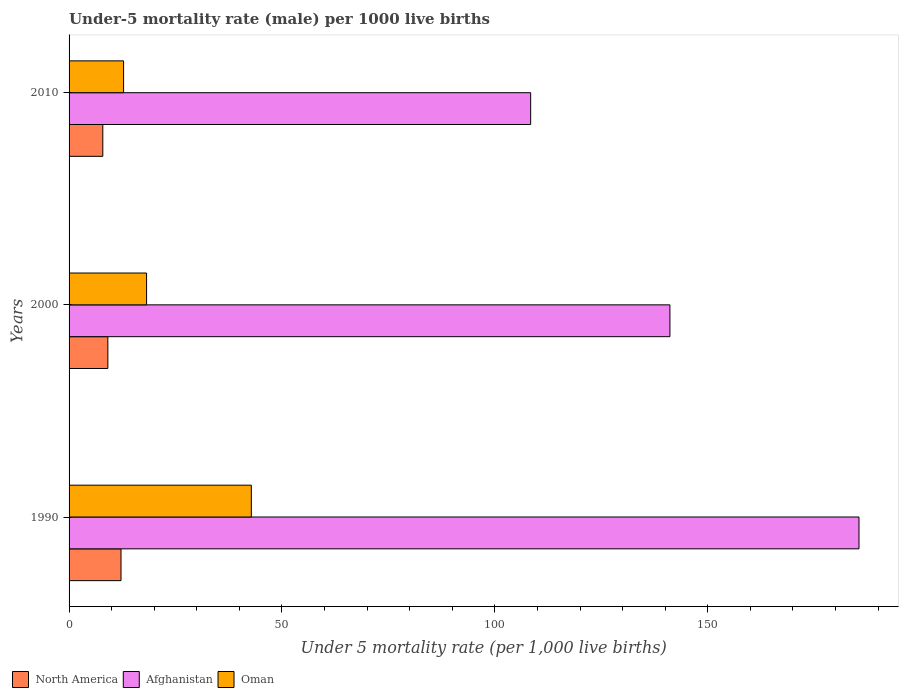Are the number of bars per tick equal to the number of legend labels?
Your answer should be compact. Yes. What is the label of the 3rd group of bars from the top?
Offer a very short reply. 1990. What is the under-five mortality rate in North America in 1990?
Provide a succinct answer. 12.2. Across all years, what is the maximum under-five mortality rate in North America?
Keep it short and to the point. 12.2. What is the total under-five mortality rate in Oman in the graph?
Provide a short and direct response. 73.8. What is the difference between the under-five mortality rate in Oman in 1990 and that in 2010?
Give a very brief answer. 30. What is the difference between the under-five mortality rate in Oman in 2010 and the under-five mortality rate in North America in 2000?
Offer a very short reply. 3.69. What is the average under-five mortality rate in Oman per year?
Make the answer very short. 24.6. In the year 2010, what is the difference between the under-five mortality rate in Oman and under-five mortality rate in Afghanistan?
Provide a succinct answer. -95.6. What is the ratio of the under-five mortality rate in Oman in 1990 to that in 2010?
Provide a short and direct response. 3.34. Is the under-five mortality rate in Afghanistan in 1990 less than that in 2010?
Your response must be concise. No. Is the difference between the under-five mortality rate in Oman in 2000 and 2010 greater than the difference between the under-five mortality rate in Afghanistan in 2000 and 2010?
Your answer should be compact. No. What is the difference between the highest and the second highest under-five mortality rate in Afghanistan?
Offer a terse response. 44.4. What is the difference between the highest and the lowest under-five mortality rate in North America?
Keep it short and to the point. 4.28. Is the sum of the under-five mortality rate in Oman in 2000 and 2010 greater than the maximum under-five mortality rate in Afghanistan across all years?
Make the answer very short. No. What does the 1st bar from the top in 2000 represents?
Offer a terse response. Oman. What does the 3rd bar from the bottom in 1990 represents?
Offer a very short reply. Oman. Is it the case that in every year, the sum of the under-five mortality rate in North America and under-five mortality rate in Afghanistan is greater than the under-five mortality rate in Oman?
Keep it short and to the point. Yes. Are all the bars in the graph horizontal?
Your answer should be very brief. Yes. Does the graph contain grids?
Offer a very short reply. No. Where does the legend appear in the graph?
Give a very brief answer. Bottom left. How are the legend labels stacked?
Keep it short and to the point. Horizontal. What is the title of the graph?
Make the answer very short. Under-5 mortality rate (male) per 1000 live births. What is the label or title of the X-axis?
Give a very brief answer. Under 5 mortality rate (per 1,0 live births). What is the label or title of the Y-axis?
Give a very brief answer. Years. What is the Under 5 mortality rate (per 1,000 live births) in North America in 1990?
Offer a very short reply. 12.2. What is the Under 5 mortality rate (per 1,000 live births) in Afghanistan in 1990?
Offer a very short reply. 185.5. What is the Under 5 mortality rate (per 1,000 live births) of Oman in 1990?
Your answer should be compact. 42.8. What is the Under 5 mortality rate (per 1,000 live births) of North America in 2000?
Keep it short and to the point. 9.11. What is the Under 5 mortality rate (per 1,000 live births) in Afghanistan in 2000?
Your response must be concise. 141.1. What is the Under 5 mortality rate (per 1,000 live births) of North America in 2010?
Your answer should be compact. 7.92. What is the Under 5 mortality rate (per 1,000 live births) of Afghanistan in 2010?
Your answer should be very brief. 108.4. Across all years, what is the maximum Under 5 mortality rate (per 1,000 live births) in North America?
Your answer should be compact. 12.2. Across all years, what is the maximum Under 5 mortality rate (per 1,000 live births) in Afghanistan?
Offer a terse response. 185.5. Across all years, what is the maximum Under 5 mortality rate (per 1,000 live births) in Oman?
Give a very brief answer. 42.8. Across all years, what is the minimum Under 5 mortality rate (per 1,000 live births) in North America?
Your answer should be very brief. 7.92. Across all years, what is the minimum Under 5 mortality rate (per 1,000 live births) in Afghanistan?
Give a very brief answer. 108.4. What is the total Under 5 mortality rate (per 1,000 live births) of North America in the graph?
Give a very brief answer. 29.23. What is the total Under 5 mortality rate (per 1,000 live births) of Afghanistan in the graph?
Offer a very short reply. 435. What is the total Under 5 mortality rate (per 1,000 live births) of Oman in the graph?
Your answer should be compact. 73.8. What is the difference between the Under 5 mortality rate (per 1,000 live births) of North America in 1990 and that in 2000?
Give a very brief answer. 3.09. What is the difference between the Under 5 mortality rate (per 1,000 live births) in Afghanistan in 1990 and that in 2000?
Your answer should be compact. 44.4. What is the difference between the Under 5 mortality rate (per 1,000 live births) of Oman in 1990 and that in 2000?
Offer a very short reply. 24.6. What is the difference between the Under 5 mortality rate (per 1,000 live births) of North America in 1990 and that in 2010?
Make the answer very short. 4.28. What is the difference between the Under 5 mortality rate (per 1,000 live births) of Afghanistan in 1990 and that in 2010?
Ensure brevity in your answer.  77.1. What is the difference between the Under 5 mortality rate (per 1,000 live births) in Oman in 1990 and that in 2010?
Keep it short and to the point. 30. What is the difference between the Under 5 mortality rate (per 1,000 live births) in North America in 2000 and that in 2010?
Your response must be concise. 1.19. What is the difference between the Under 5 mortality rate (per 1,000 live births) in Afghanistan in 2000 and that in 2010?
Give a very brief answer. 32.7. What is the difference between the Under 5 mortality rate (per 1,000 live births) in Oman in 2000 and that in 2010?
Keep it short and to the point. 5.4. What is the difference between the Under 5 mortality rate (per 1,000 live births) of North America in 1990 and the Under 5 mortality rate (per 1,000 live births) of Afghanistan in 2000?
Your response must be concise. -128.9. What is the difference between the Under 5 mortality rate (per 1,000 live births) in North America in 1990 and the Under 5 mortality rate (per 1,000 live births) in Oman in 2000?
Make the answer very short. -6. What is the difference between the Under 5 mortality rate (per 1,000 live births) in Afghanistan in 1990 and the Under 5 mortality rate (per 1,000 live births) in Oman in 2000?
Offer a very short reply. 167.3. What is the difference between the Under 5 mortality rate (per 1,000 live births) in North America in 1990 and the Under 5 mortality rate (per 1,000 live births) in Afghanistan in 2010?
Make the answer very short. -96.2. What is the difference between the Under 5 mortality rate (per 1,000 live births) of North America in 1990 and the Under 5 mortality rate (per 1,000 live births) of Oman in 2010?
Make the answer very short. -0.6. What is the difference between the Under 5 mortality rate (per 1,000 live births) in Afghanistan in 1990 and the Under 5 mortality rate (per 1,000 live births) in Oman in 2010?
Your answer should be compact. 172.7. What is the difference between the Under 5 mortality rate (per 1,000 live births) of North America in 2000 and the Under 5 mortality rate (per 1,000 live births) of Afghanistan in 2010?
Ensure brevity in your answer.  -99.29. What is the difference between the Under 5 mortality rate (per 1,000 live births) in North America in 2000 and the Under 5 mortality rate (per 1,000 live births) in Oman in 2010?
Your response must be concise. -3.69. What is the difference between the Under 5 mortality rate (per 1,000 live births) of Afghanistan in 2000 and the Under 5 mortality rate (per 1,000 live births) of Oman in 2010?
Provide a short and direct response. 128.3. What is the average Under 5 mortality rate (per 1,000 live births) of North America per year?
Make the answer very short. 9.74. What is the average Under 5 mortality rate (per 1,000 live births) in Afghanistan per year?
Your answer should be compact. 145. What is the average Under 5 mortality rate (per 1,000 live births) in Oman per year?
Offer a very short reply. 24.6. In the year 1990, what is the difference between the Under 5 mortality rate (per 1,000 live births) in North America and Under 5 mortality rate (per 1,000 live births) in Afghanistan?
Your answer should be very brief. -173.3. In the year 1990, what is the difference between the Under 5 mortality rate (per 1,000 live births) in North America and Under 5 mortality rate (per 1,000 live births) in Oman?
Make the answer very short. -30.6. In the year 1990, what is the difference between the Under 5 mortality rate (per 1,000 live births) of Afghanistan and Under 5 mortality rate (per 1,000 live births) of Oman?
Offer a very short reply. 142.7. In the year 2000, what is the difference between the Under 5 mortality rate (per 1,000 live births) of North America and Under 5 mortality rate (per 1,000 live births) of Afghanistan?
Make the answer very short. -131.99. In the year 2000, what is the difference between the Under 5 mortality rate (per 1,000 live births) in North America and Under 5 mortality rate (per 1,000 live births) in Oman?
Offer a terse response. -9.09. In the year 2000, what is the difference between the Under 5 mortality rate (per 1,000 live births) in Afghanistan and Under 5 mortality rate (per 1,000 live births) in Oman?
Provide a succinct answer. 122.9. In the year 2010, what is the difference between the Under 5 mortality rate (per 1,000 live births) in North America and Under 5 mortality rate (per 1,000 live births) in Afghanistan?
Provide a succinct answer. -100.48. In the year 2010, what is the difference between the Under 5 mortality rate (per 1,000 live births) in North America and Under 5 mortality rate (per 1,000 live births) in Oman?
Provide a succinct answer. -4.88. In the year 2010, what is the difference between the Under 5 mortality rate (per 1,000 live births) in Afghanistan and Under 5 mortality rate (per 1,000 live births) in Oman?
Ensure brevity in your answer.  95.6. What is the ratio of the Under 5 mortality rate (per 1,000 live births) in North America in 1990 to that in 2000?
Make the answer very short. 1.34. What is the ratio of the Under 5 mortality rate (per 1,000 live births) of Afghanistan in 1990 to that in 2000?
Your answer should be very brief. 1.31. What is the ratio of the Under 5 mortality rate (per 1,000 live births) of Oman in 1990 to that in 2000?
Give a very brief answer. 2.35. What is the ratio of the Under 5 mortality rate (per 1,000 live births) of North America in 1990 to that in 2010?
Give a very brief answer. 1.54. What is the ratio of the Under 5 mortality rate (per 1,000 live births) in Afghanistan in 1990 to that in 2010?
Make the answer very short. 1.71. What is the ratio of the Under 5 mortality rate (per 1,000 live births) in Oman in 1990 to that in 2010?
Provide a succinct answer. 3.34. What is the ratio of the Under 5 mortality rate (per 1,000 live births) in North America in 2000 to that in 2010?
Give a very brief answer. 1.15. What is the ratio of the Under 5 mortality rate (per 1,000 live births) of Afghanistan in 2000 to that in 2010?
Offer a terse response. 1.3. What is the ratio of the Under 5 mortality rate (per 1,000 live births) of Oman in 2000 to that in 2010?
Make the answer very short. 1.42. What is the difference between the highest and the second highest Under 5 mortality rate (per 1,000 live births) in North America?
Provide a succinct answer. 3.09. What is the difference between the highest and the second highest Under 5 mortality rate (per 1,000 live births) in Afghanistan?
Ensure brevity in your answer.  44.4. What is the difference between the highest and the second highest Under 5 mortality rate (per 1,000 live births) in Oman?
Provide a succinct answer. 24.6. What is the difference between the highest and the lowest Under 5 mortality rate (per 1,000 live births) in North America?
Your answer should be compact. 4.28. What is the difference between the highest and the lowest Under 5 mortality rate (per 1,000 live births) of Afghanistan?
Ensure brevity in your answer.  77.1. What is the difference between the highest and the lowest Under 5 mortality rate (per 1,000 live births) in Oman?
Keep it short and to the point. 30. 